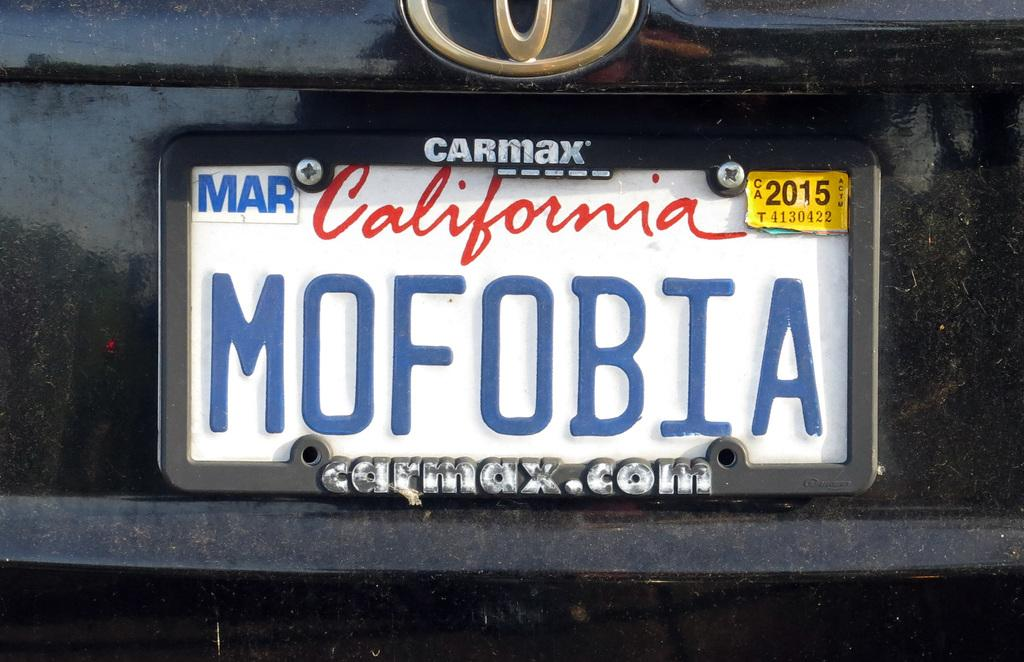<image>
Write a terse but informative summary of the picture. A california plate saying mofobia that expires in March. 